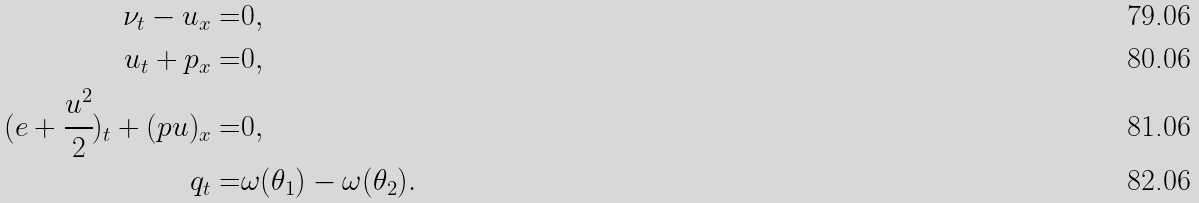Convert formula to latex. <formula><loc_0><loc_0><loc_500><loc_500>\nu _ { t } - u _ { x } = & 0 , \\ u _ { t } + p _ { x } = & 0 , \\ ( e + \cfrac { u ^ { 2 } } { 2 } ) _ { t } + ( p u ) _ { x } = & 0 , \\ q _ { t } = & \omega ( \theta _ { 1 } ) - \omega ( \theta _ { 2 } ) .</formula> 